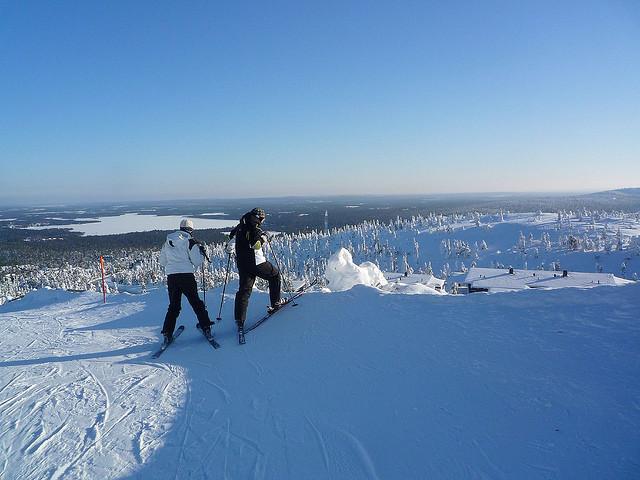How many people are shown?
Answer briefly. 2. Is the photographer circling overhead?
Quick response, please. No. Are they wearing shorts?
Concise answer only. No. Is there a building in the background?
Short answer required. No. 